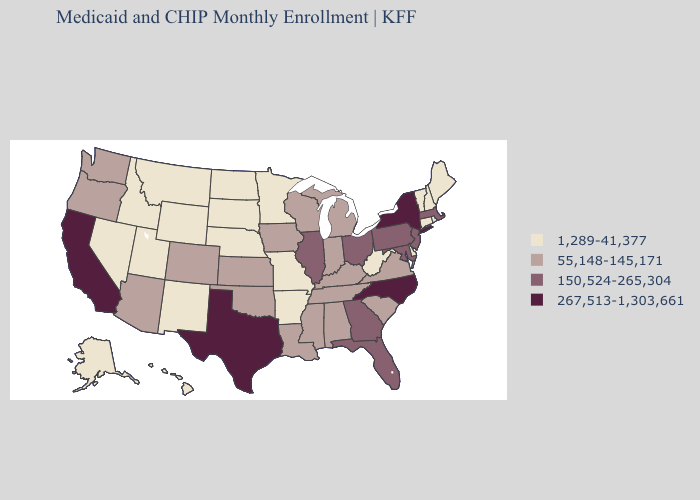What is the value of Minnesota?
Short answer required. 1,289-41,377. Among the states that border Florida , which have the highest value?
Write a very short answer. Georgia. Which states have the highest value in the USA?
Short answer required. California, New York, North Carolina, Texas. Does Tennessee have the lowest value in the USA?
Concise answer only. No. Does Florida have the highest value in the South?
Keep it brief. No. What is the highest value in states that border Rhode Island?
Concise answer only. 150,524-265,304. What is the lowest value in the USA?
Quick response, please. 1,289-41,377. What is the value of Iowa?
Write a very short answer. 55,148-145,171. Name the states that have a value in the range 267,513-1,303,661?
Keep it brief. California, New York, North Carolina, Texas. Does Arkansas have the lowest value in the South?
Quick response, please. Yes. Name the states that have a value in the range 150,524-265,304?
Quick response, please. Florida, Georgia, Illinois, Maryland, Massachusetts, New Jersey, Ohio, Pennsylvania. Name the states that have a value in the range 267,513-1,303,661?
Short answer required. California, New York, North Carolina, Texas. Which states have the lowest value in the USA?
Write a very short answer. Alaska, Arkansas, Connecticut, Delaware, Hawaii, Idaho, Maine, Minnesota, Missouri, Montana, Nebraska, Nevada, New Hampshire, New Mexico, North Dakota, Rhode Island, South Dakota, Utah, Vermont, West Virginia, Wyoming. What is the highest value in the USA?
Answer briefly. 267,513-1,303,661. 